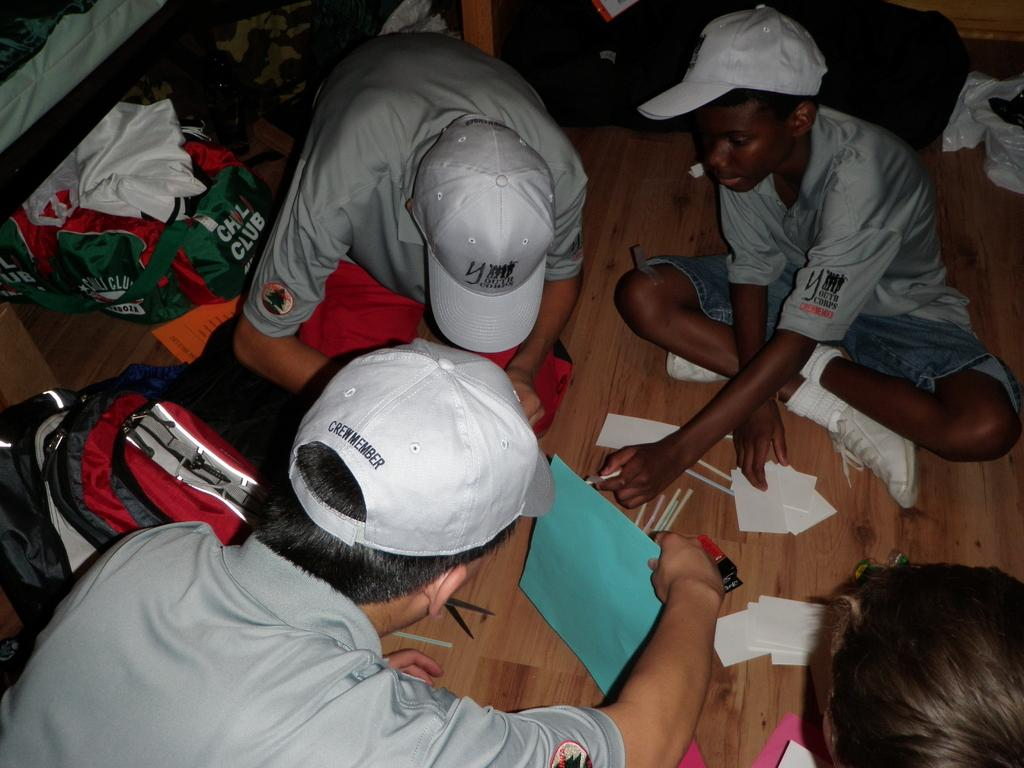How many people are in the image? There are three persons in the image. What are the three persons wearing? The three persons are wearing caps. Where are the three persons sitting? The three persons are sitting on the floor. How many bags can be seen in the image? There are two bags in the image. Is there anyone else in the image besides the three persons? Yes, there is one person sitting in front of the three persons. What type of corn is growing on the tree in the image? There is no tree or corn present in the image. How does the cannon affect the scene in the image? There is no cannon present in the image, so it cannot affect the scene. 